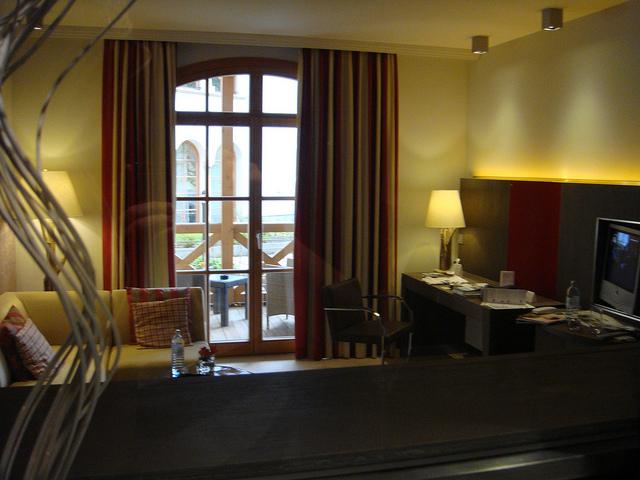Is the spiral shape functional or decorative?
Keep it brief. Decorative. What kind of lights are in the picture?
Give a very brief answer. Lamp. How many lamps are on?
Short answer required. 2. Where are the railings?
Short answer required. Outside. Does this door lead to a balcony?
Quick response, please. Yes. 